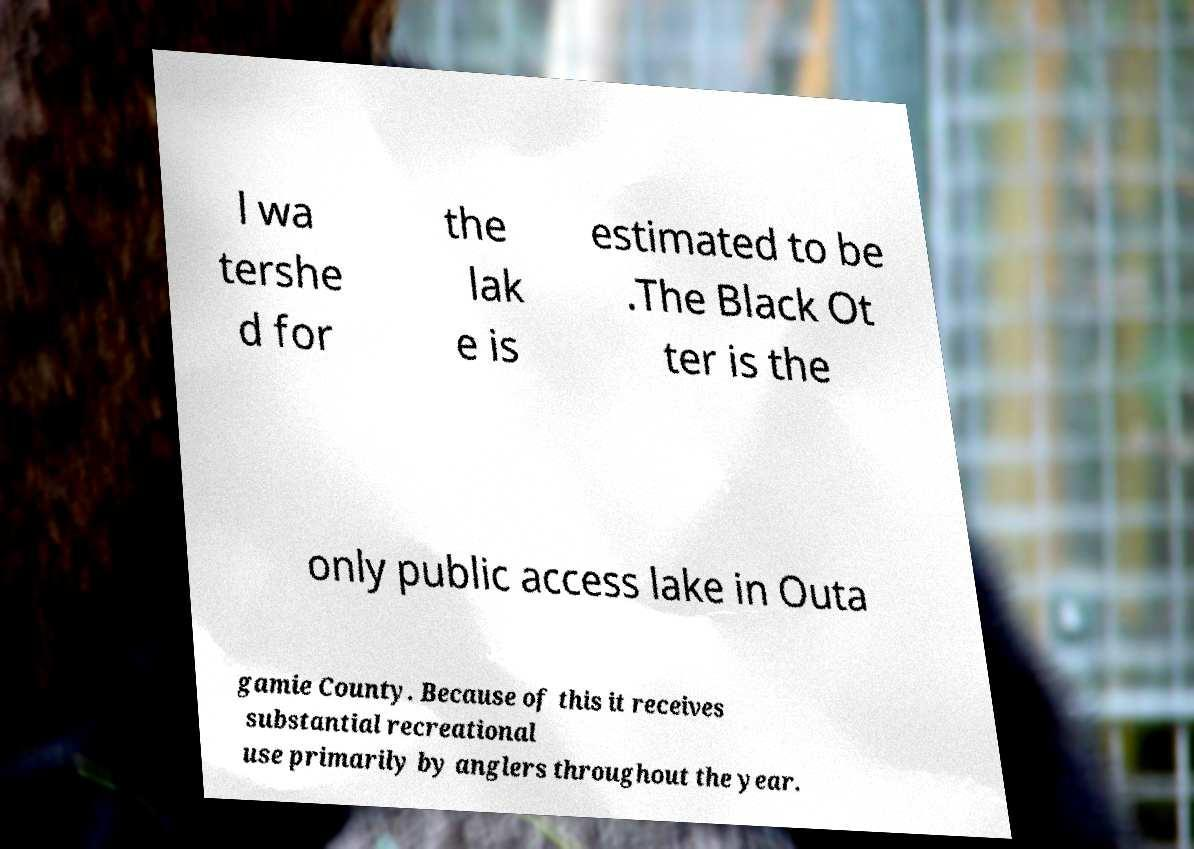For documentation purposes, I need the text within this image transcribed. Could you provide that? l wa tershe d for the lak e is estimated to be .The Black Ot ter is the only public access lake in Outa gamie County. Because of this it receives substantial recreational use primarily by anglers throughout the year. 